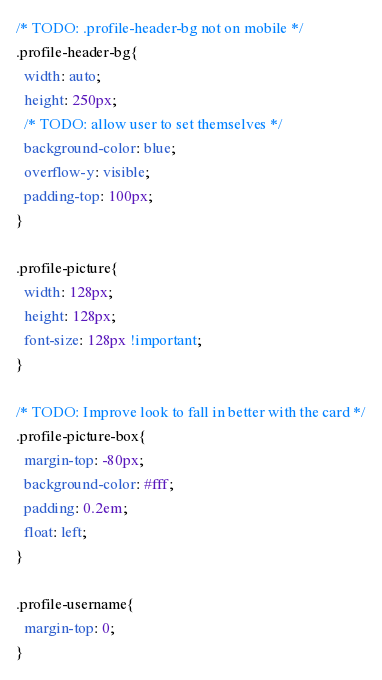<code> <loc_0><loc_0><loc_500><loc_500><_CSS_>/* TODO: .profile-header-bg not on mobile */
.profile-header-bg{
  width: auto;
  height: 250px;
  /* TODO: allow user to set themselves */
  background-color: blue;
  overflow-y: visible;
  padding-top: 100px;
}

.profile-picture{
  width: 128px;
  height: 128px;
  font-size: 128px !important;
}

/* TODO: Improve look to fall in better with the card */
.profile-picture-box{
  margin-top: -80px;
  background-color: #fff;
  padding: 0.2em;
  float: left;
}

.profile-username{
  margin-top: 0;
}
</code> 